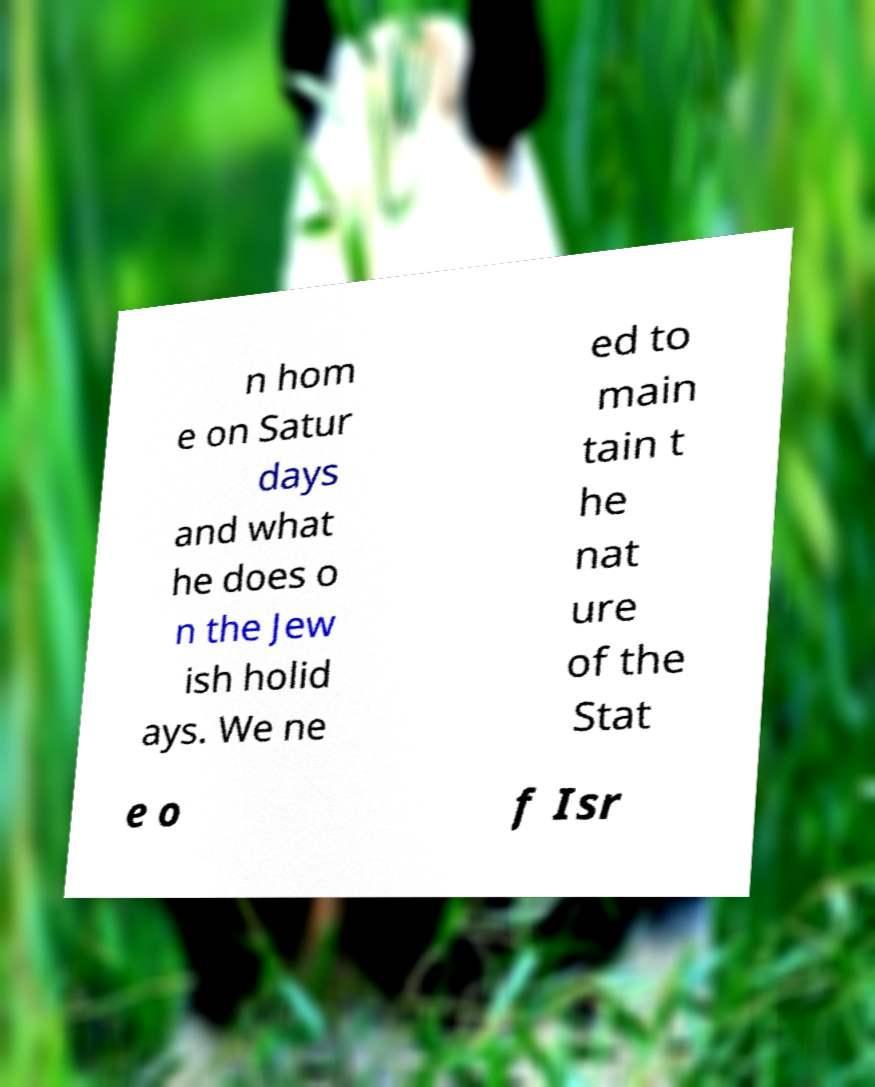What messages or text are displayed in this image? I need them in a readable, typed format. n hom e on Satur days and what he does o n the Jew ish holid ays. We ne ed to main tain t he nat ure of the Stat e o f Isr 